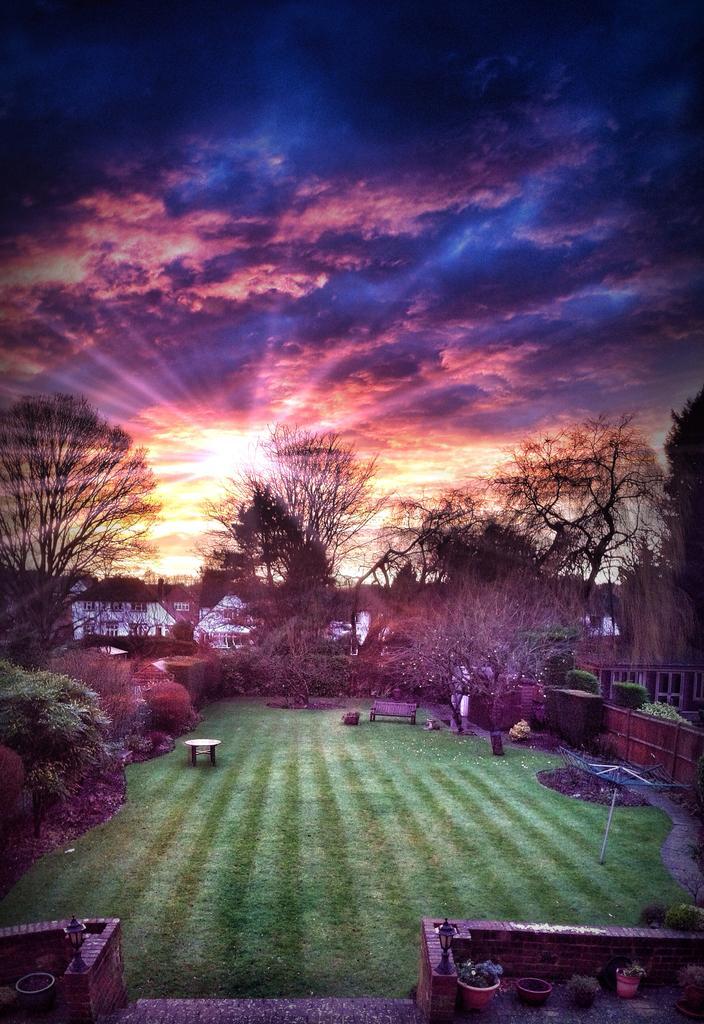In one or two sentences, can you explain what this image depicts? In this picture I can see trees, plants, grass, plant pots and other objects on the ground. In the background I can see the sky and the sun. 